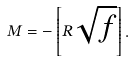<formula> <loc_0><loc_0><loc_500><loc_500>M = - \left [ R \sqrt { f } \right ] .</formula> 